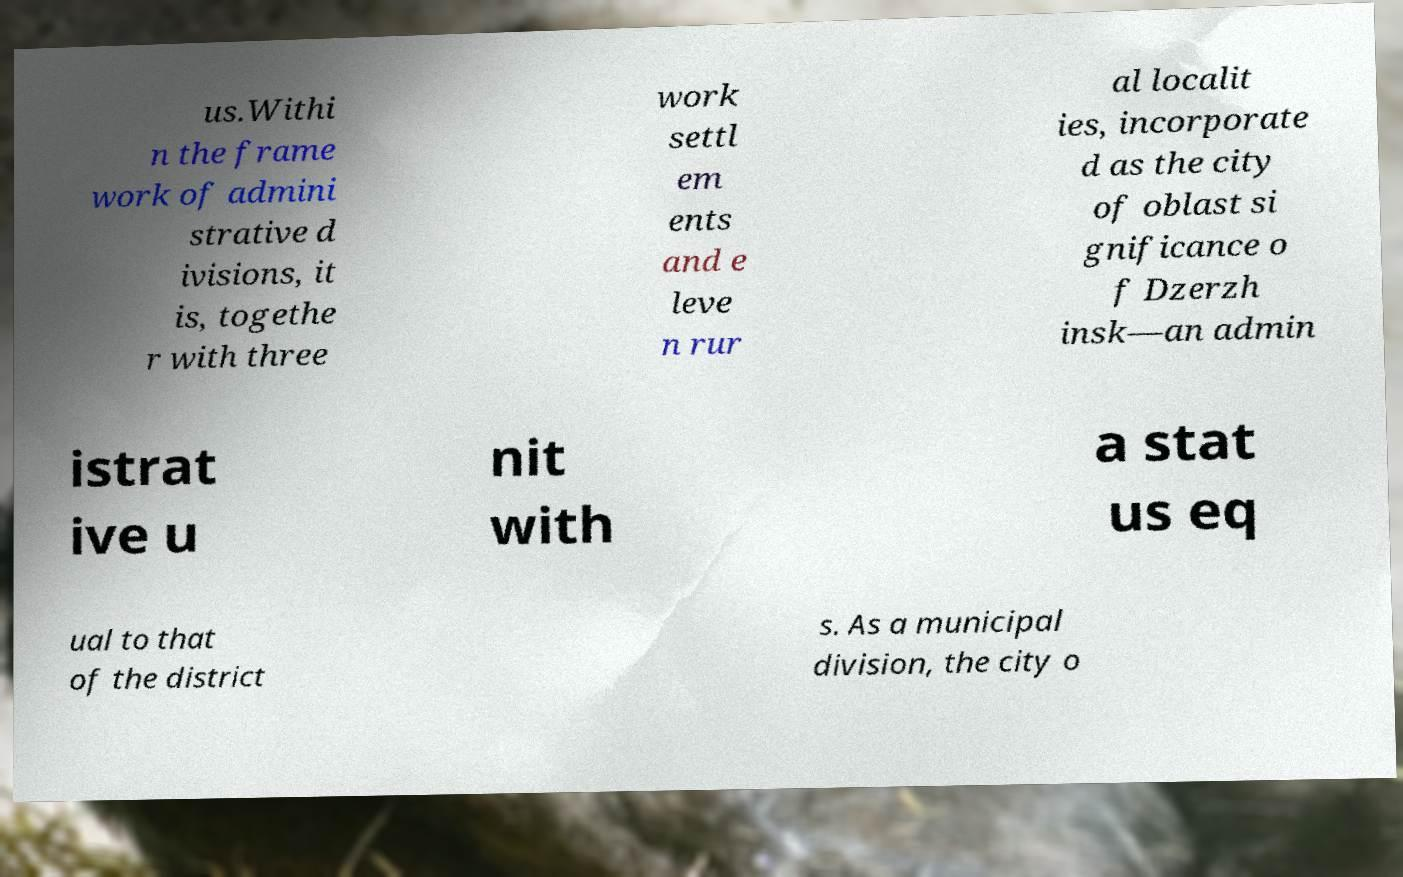Can you read and provide the text displayed in the image?This photo seems to have some interesting text. Can you extract and type it out for me? us.Withi n the frame work of admini strative d ivisions, it is, togethe r with three work settl em ents and e leve n rur al localit ies, incorporate d as the city of oblast si gnificance o f Dzerzh insk—an admin istrat ive u nit with a stat us eq ual to that of the district s. As a municipal division, the city o 